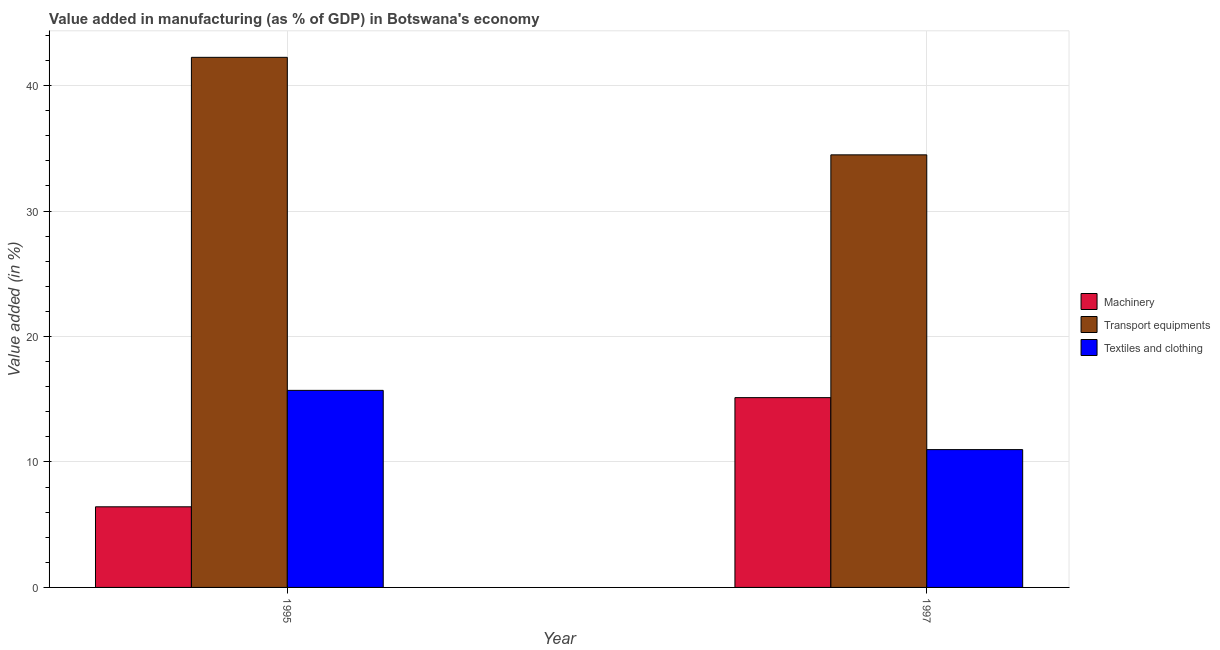Are the number of bars on each tick of the X-axis equal?
Give a very brief answer. Yes. How many bars are there on the 1st tick from the left?
Provide a succinct answer. 3. In how many cases, is the number of bars for a given year not equal to the number of legend labels?
Keep it short and to the point. 0. What is the value added in manufacturing textile and clothing in 1997?
Offer a terse response. 10.99. Across all years, what is the maximum value added in manufacturing textile and clothing?
Your response must be concise. 15.71. Across all years, what is the minimum value added in manufacturing textile and clothing?
Give a very brief answer. 10.99. In which year was the value added in manufacturing textile and clothing maximum?
Offer a very short reply. 1995. What is the total value added in manufacturing transport equipments in the graph?
Offer a terse response. 76.74. What is the difference between the value added in manufacturing machinery in 1995 and that in 1997?
Offer a terse response. -8.7. What is the difference between the value added in manufacturing machinery in 1997 and the value added in manufacturing textile and clothing in 1995?
Ensure brevity in your answer.  8.7. What is the average value added in manufacturing textile and clothing per year?
Provide a succinct answer. 13.35. In the year 1995, what is the difference between the value added in manufacturing machinery and value added in manufacturing textile and clothing?
Your answer should be compact. 0. What is the ratio of the value added in manufacturing transport equipments in 1995 to that in 1997?
Provide a short and direct response. 1.23. What does the 1st bar from the left in 1995 represents?
Offer a very short reply. Machinery. What does the 1st bar from the right in 1995 represents?
Your answer should be compact. Textiles and clothing. Are all the bars in the graph horizontal?
Your answer should be very brief. No. How many years are there in the graph?
Provide a short and direct response. 2. What is the difference between two consecutive major ticks on the Y-axis?
Ensure brevity in your answer.  10. Does the graph contain grids?
Your answer should be very brief. Yes. What is the title of the graph?
Your answer should be very brief. Value added in manufacturing (as % of GDP) in Botswana's economy. What is the label or title of the Y-axis?
Ensure brevity in your answer.  Value added (in %). What is the Value added (in %) of Machinery in 1995?
Your answer should be compact. 6.43. What is the Value added (in %) in Transport equipments in 1995?
Offer a terse response. 42.26. What is the Value added (in %) in Textiles and clothing in 1995?
Provide a short and direct response. 15.71. What is the Value added (in %) of Machinery in 1997?
Make the answer very short. 15.13. What is the Value added (in %) in Transport equipments in 1997?
Offer a very short reply. 34.48. What is the Value added (in %) of Textiles and clothing in 1997?
Your response must be concise. 10.99. Across all years, what is the maximum Value added (in %) of Machinery?
Keep it short and to the point. 15.13. Across all years, what is the maximum Value added (in %) in Transport equipments?
Ensure brevity in your answer.  42.26. Across all years, what is the maximum Value added (in %) in Textiles and clothing?
Offer a terse response. 15.71. Across all years, what is the minimum Value added (in %) in Machinery?
Keep it short and to the point. 6.43. Across all years, what is the minimum Value added (in %) of Transport equipments?
Keep it short and to the point. 34.48. Across all years, what is the minimum Value added (in %) of Textiles and clothing?
Keep it short and to the point. 10.99. What is the total Value added (in %) in Machinery in the graph?
Give a very brief answer. 21.56. What is the total Value added (in %) of Transport equipments in the graph?
Your response must be concise. 76.74. What is the total Value added (in %) of Textiles and clothing in the graph?
Provide a short and direct response. 26.69. What is the difference between the Value added (in %) of Machinery in 1995 and that in 1997?
Keep it short and to the point. -8.7. What is the difference between the Value added (in %) in Transport equipments in 1995 and that in 1997?
Provide a short and direct response. 7.77. What is the difference between the Value added (in %) in Textiles and clothing in 1995 and that in 1997?
Provide a succinct answer. 4.72. What is the difference between the Value added (in %) in Machinery in 1995 and the Value added (in %) in Transport equipments in 1997?
Provide a short and direct response. -28.06. What is the difference between the Value added (in %) in Machinery in 1995 and the Value added (in %) in Textiles and clothing in 1997?
Ensure brevity in your answer.  -4.56. What is the difference between the Value added (in %) in Transport equipments in 1995 and the Value added (in %) in Textiles and clothing in 1997?
Provide a short and direct response. 31.27. What is the average Value added (in %) of Machinery per year?
Your answer should be compact. 10.78. What is the average Value added (in %) of Transport equipments per year?
Keep it short and to the point. 38.37. What is the average Value added (in %) in Textiles and clothing per year?
Provide a short and direct response. 13.35. In the year 1995, what is the difference between the Value added (in %) of Machinery and Value added (in %) of Transport equipments?
Offer a terse response. -35.83. In the year 1995, what is the difference between the Value added (in %) in Machinery and Value added (in %) in Textiles and clothing?
Your answer should be very brief. -9.28. In the year 1995, what is the difference between the Value added (in %) of Transport equipments and Value added (in %) of Textiles and clothing?
Your answer should be very brief. 26.55. In the year 1997, what is the difference between the Value added (in %) of Machinery and Value added (in %) of Transport equipments?
Give a very brief answer. -19.35. In the year 1997, what is the difference between the Value added (in %) of Machinery and Value added (in %) of Textiles and clothing?
Offer a terse response. 4.14. In the year 1997, what is the difference between the Value added (in %) in Transport equipments and Value added (in %) in Textiles and clothing?
Provide a short and direct response. 23.5. What is the ratio of the Value added (in %) in Machinery in 1995 to that in 1997?
Make the answer very short. 0.42. What is the ratio of the Value added (in %) of Transport equipments in 1995 to that in 1997?
Your response must be concise. 1.23. What is the ratio of the Value added (in %) in Textiles and clothing in 1995 to that in 1997?
Ensure brevity in your answer.  1.43. What is the difference between the highest and the second highest Value added (in %) of Machinery?
Your answer should be compact. 8.7. What is the difference between the highest and the second highest Value added (in %) in Transport equipments?
Provide a succinct answer. 7.77. What is the difference between the highest and the second highest Value added (in %) in Textiles and clothing?
Your response must be concise. 4.72. What is the difference between the highest and the lowest Value added (in %) of Machinery?
Ensure brevity in your answer.  8.7. What is the difference between the highest and the lowest Value added (in %) in Transport equipments?
Give a very brief answer. 7.77. What is the difference between the highest and the lowest Value added (in %) in Textiles and clothing?
Your answer should be very brief. 4.72. 